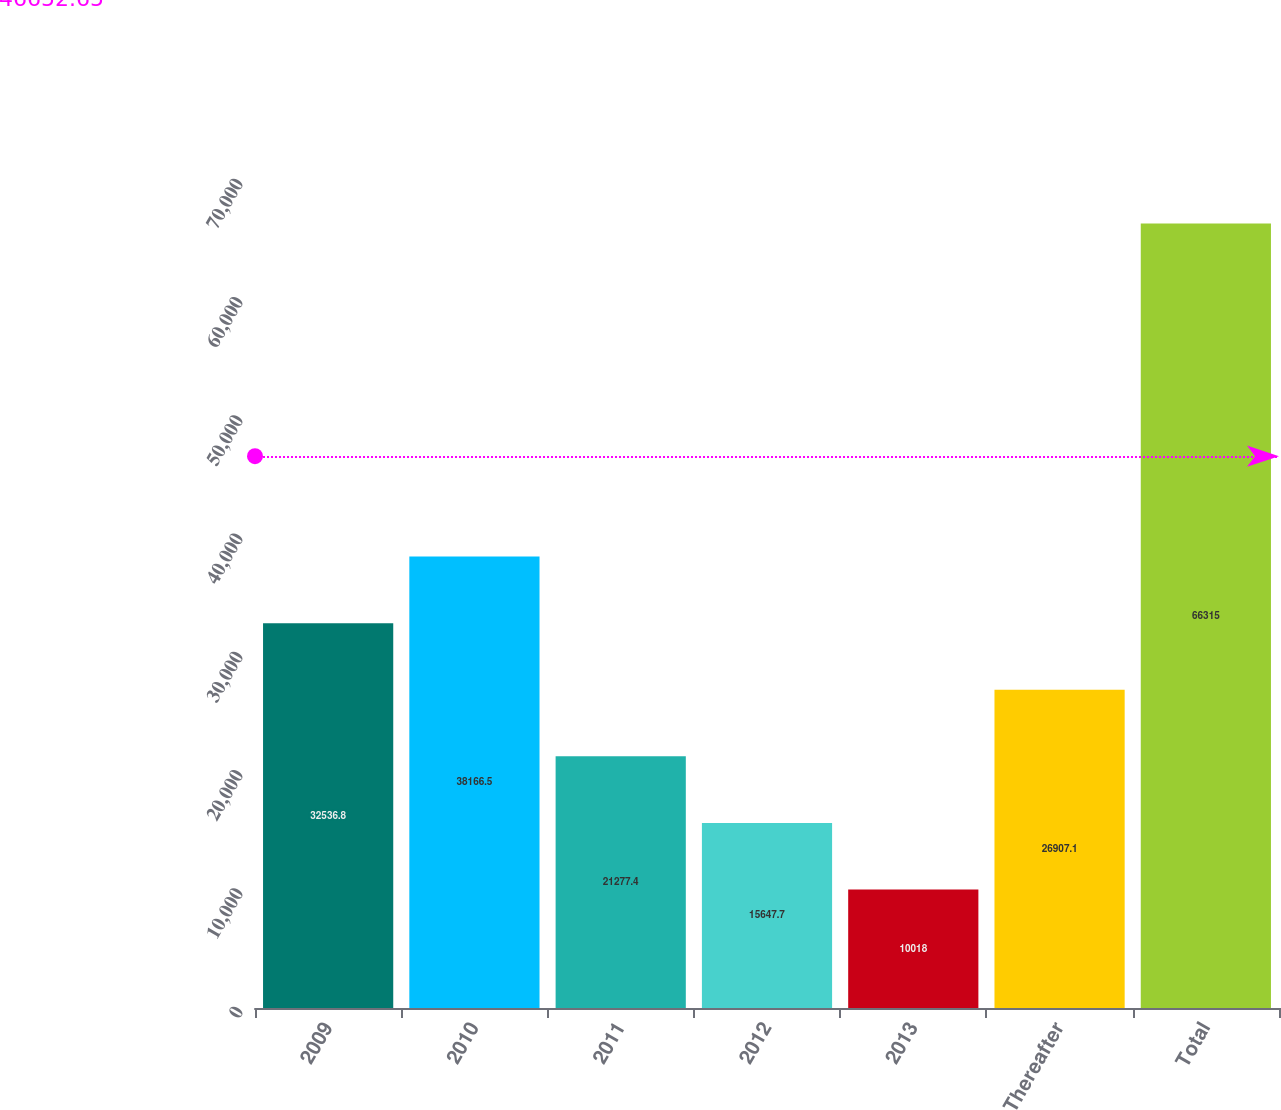Convert chart. <chart><loc_0><loc_0><loc_500><loc_500><bar_chart><fcel>2009<fcel>2010<fcel>2011<fcel>2012<fcel>2013<fcel>Thereafter<fcel>Total<nl><fcel>32536.8<fcel>38166.5<fcel>21277.4<fcel>15647.7<fcel>10018<fcel>26907.1<fcel>66315<nl></chart> 